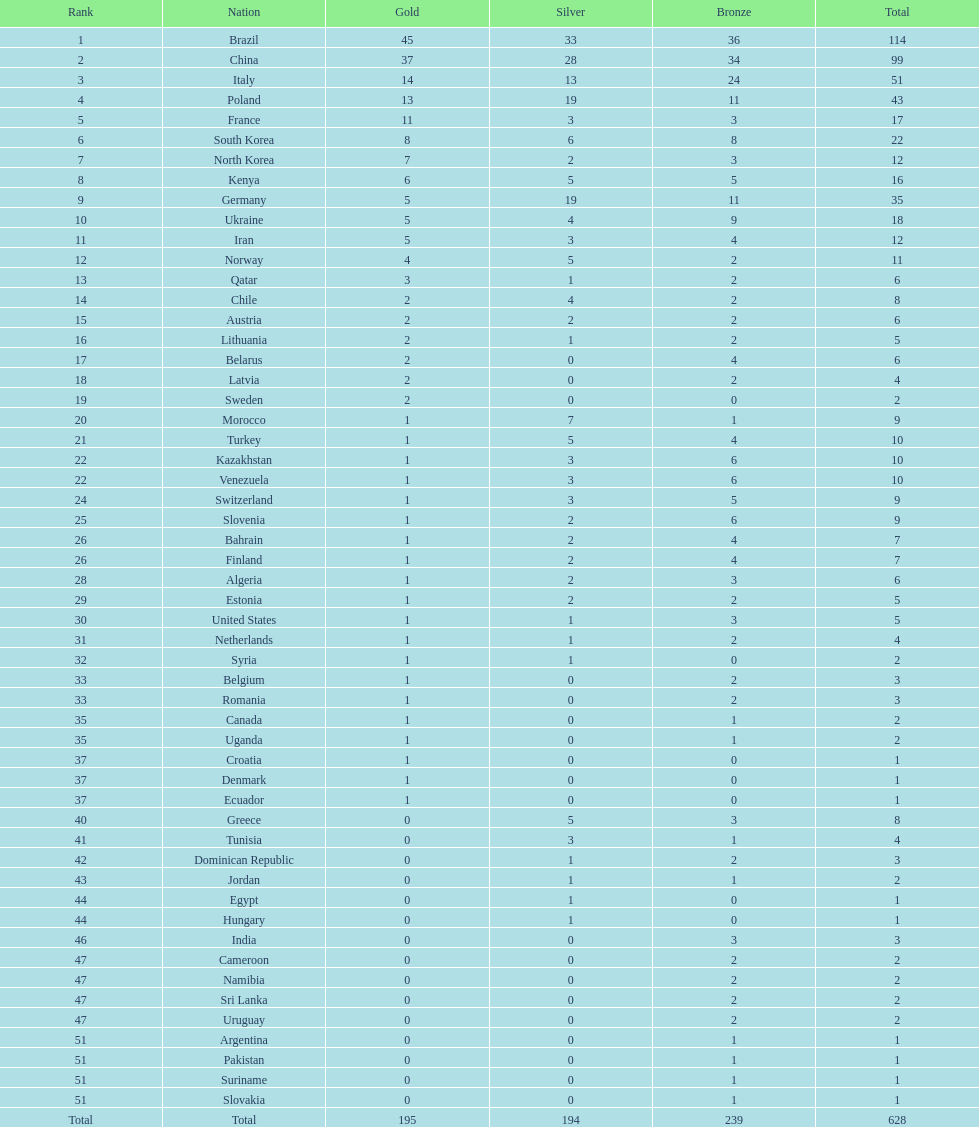How many gold medals were earned by germany? 5. 